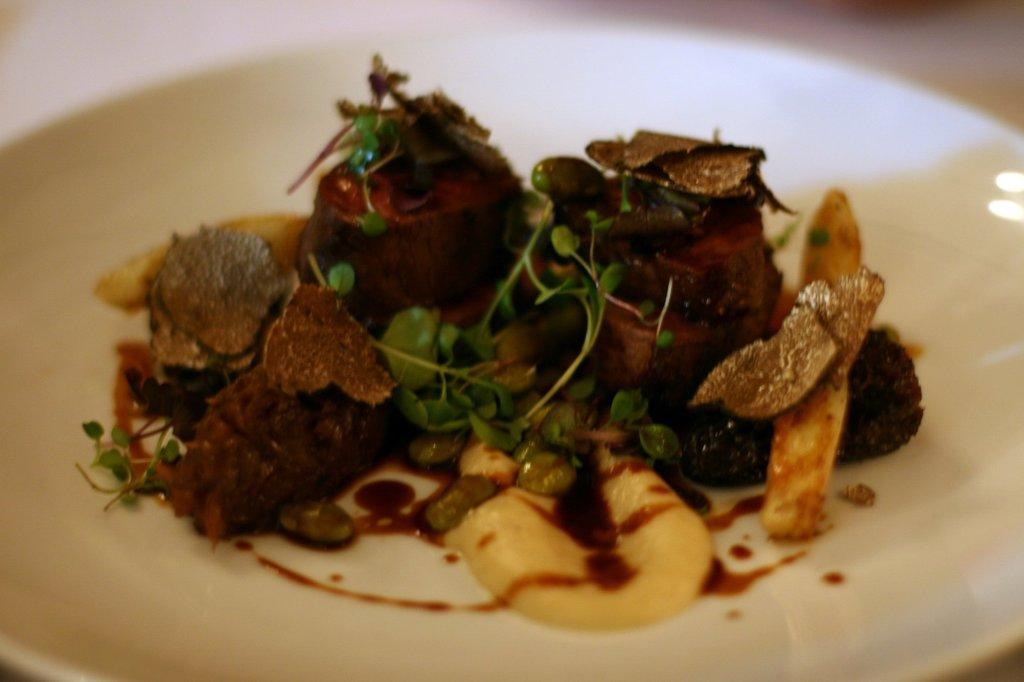What is the main subject of the image? There is a food item on a plate in the image. Can you describe the background of the image? The background of the image is blurred. What type of cable is connected to the food item in the image? There is no cable connected to the food item in the image. What is the significance of the mark on the plate in the image? There is no mark on the plate in the image. 